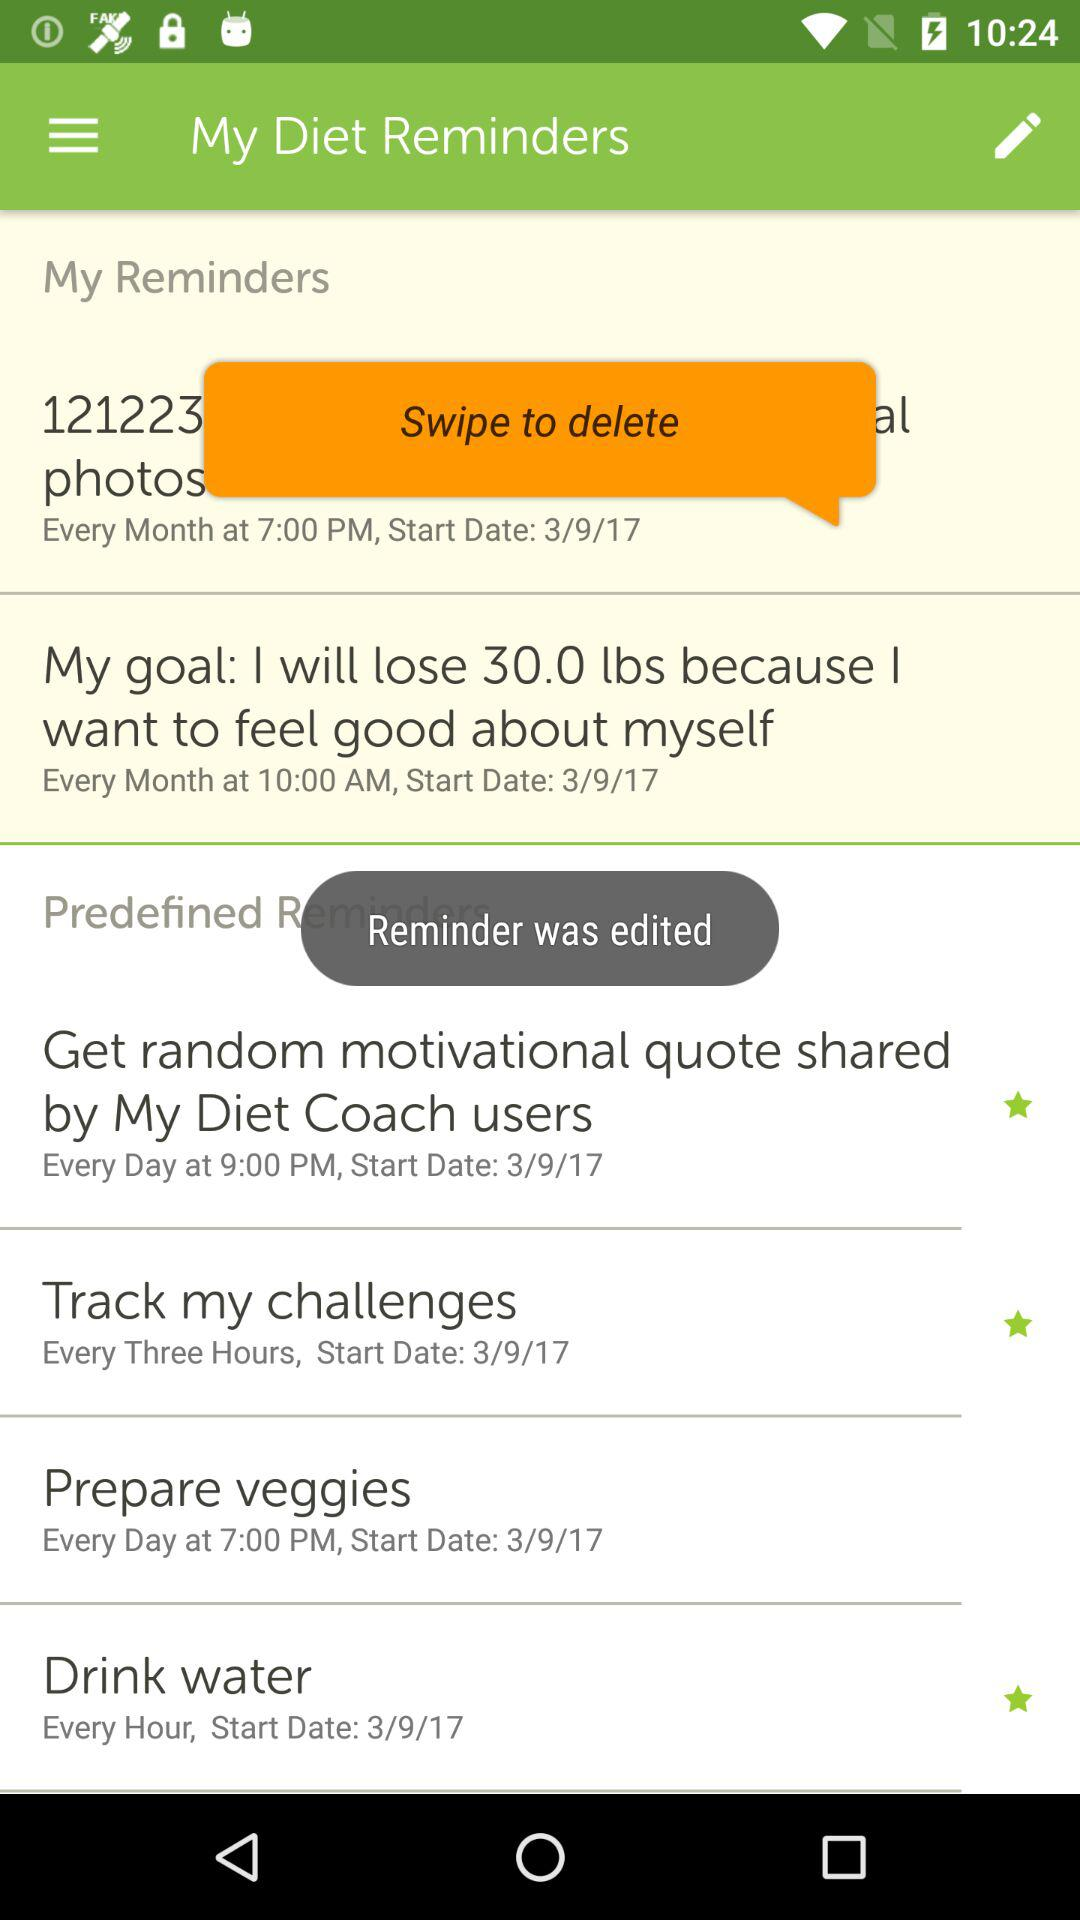Was the reminder edited? The reminder was edited. 